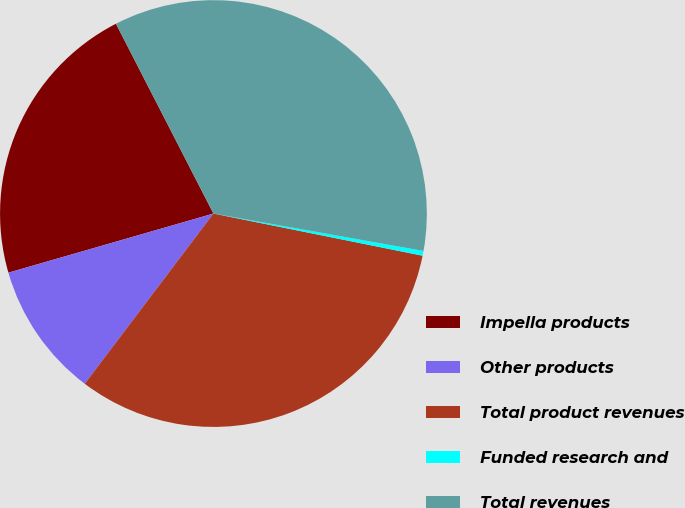<chart> <loc_0><loc_0><loc_500><loc_500><pie_chart><fcel>Impella products<fcel>Other products<fcel>Total product revenues<fcel>Funded research and<fcel>Total revenues<nl><fcel>21.92%<fcel>10.23%<fcel>32.14%<fcel>0.36%<fcel>35.36%<nl></chart> 